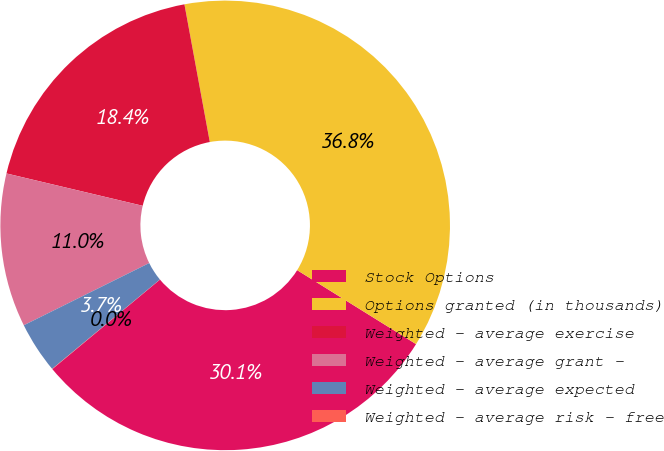<chart> <loc_0><loc_0><loc_500><loc_500><pie_chart><fcel>Stock Options<fcel>Options granted (in thousands)<fcel>Weighted - average exercise<fcel>Weighted - average grant -<fcel>Weighted - average expected<fcel>Weighted - average risk - free<nl><fcel>30.11%<fcel>36.76%<fcel>18.39%<fcel>11.04%<fcel>3.69%<fcel>0.02%<nl></chart> 